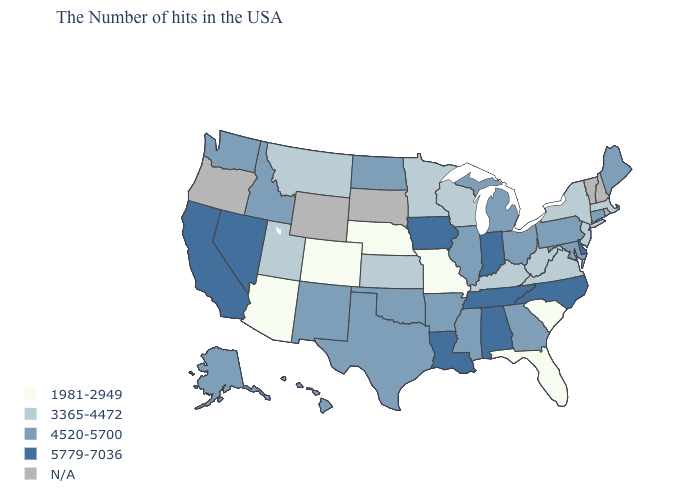Name the states that have a value in the range 4520-5700?
Short answer required. Maine, Connecticut, Maryland, Pennsylvania, Ohio, Georgia, Michigan, Illinois, Mississippi, Arkansas, Oklahoma, Texas, North Dakota, New Mexico, Idaho, Washington, Alaska, Hawaii. Which states have the highest value in the USA?
Keep it brief. Delaware, North Carolina, Indiana, Alabama, Tennessee, Louisiana, Iowa, Nevada, California. What is the value of Oklahoma?
Concise answer only. 4520-5700. How many symbols are there in the legend?
Give a very brief answer. 5. Which states have the highest value in the USA?
Write a very short answer. Delaware, North Carolina, Indiana, Alabama, Tennessee, Louisiana, Iowa, Nevada, California. What is the lowest value in states that border Oregon?
Write a very short answer. 4520-5700. Name the states that have a value in the range 5779-7036?
Be succinct. Delaware, North Carolina, Indiana, Alabama, Tennessee, Louisiana, Iowa, Nevada, California. What is the value of New Hampshire?
Give a very brief answer. N/A. Which states have the lowest value in the MidWest?
Short answer required. Missouri, Nebraska. What is the value of Tennessee?
Quick response, please. 5779-7036. Does Pennsylvania have the lowest value in the Northeast?
Short answer required. No. Name the states that have a value in the range N/A?
Short answer required. Rhode Island, New Hampshire, Vermont, South Dakota, Wyoming, Oregon. What is the lowest value in the Northeast?
Write a very short answer. 3365-4472. 